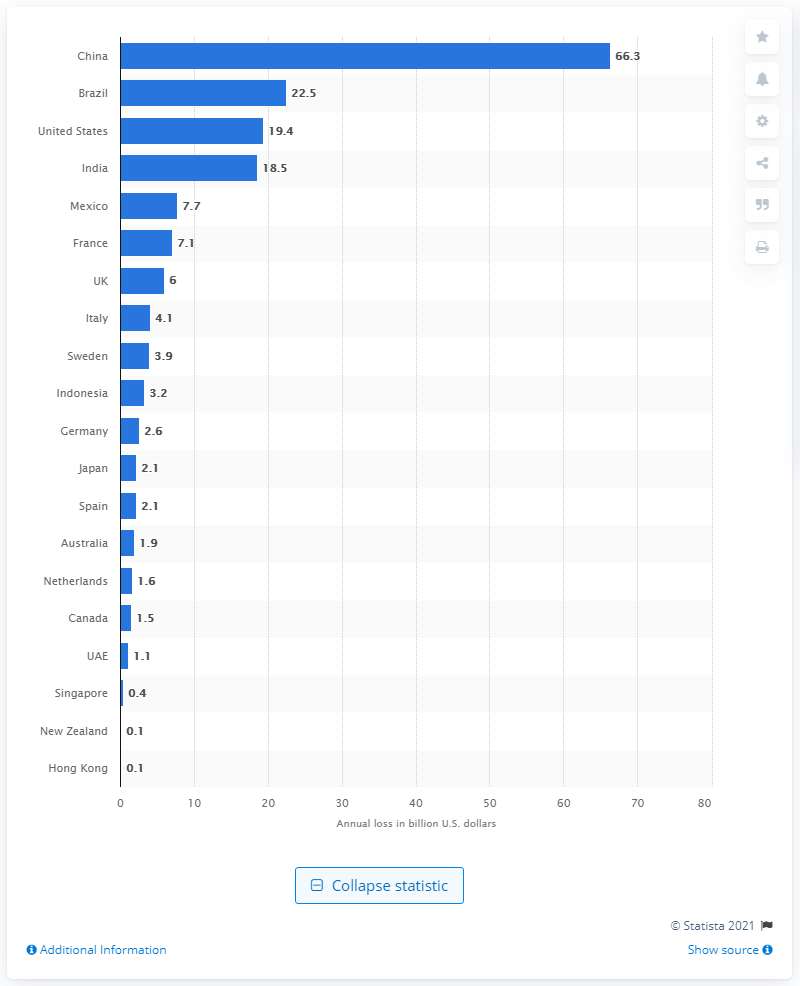Mention a couple of crucial points in this snapshot. In Brazil, consumers experienced losses of 22.5 billion U.S. dollars. 